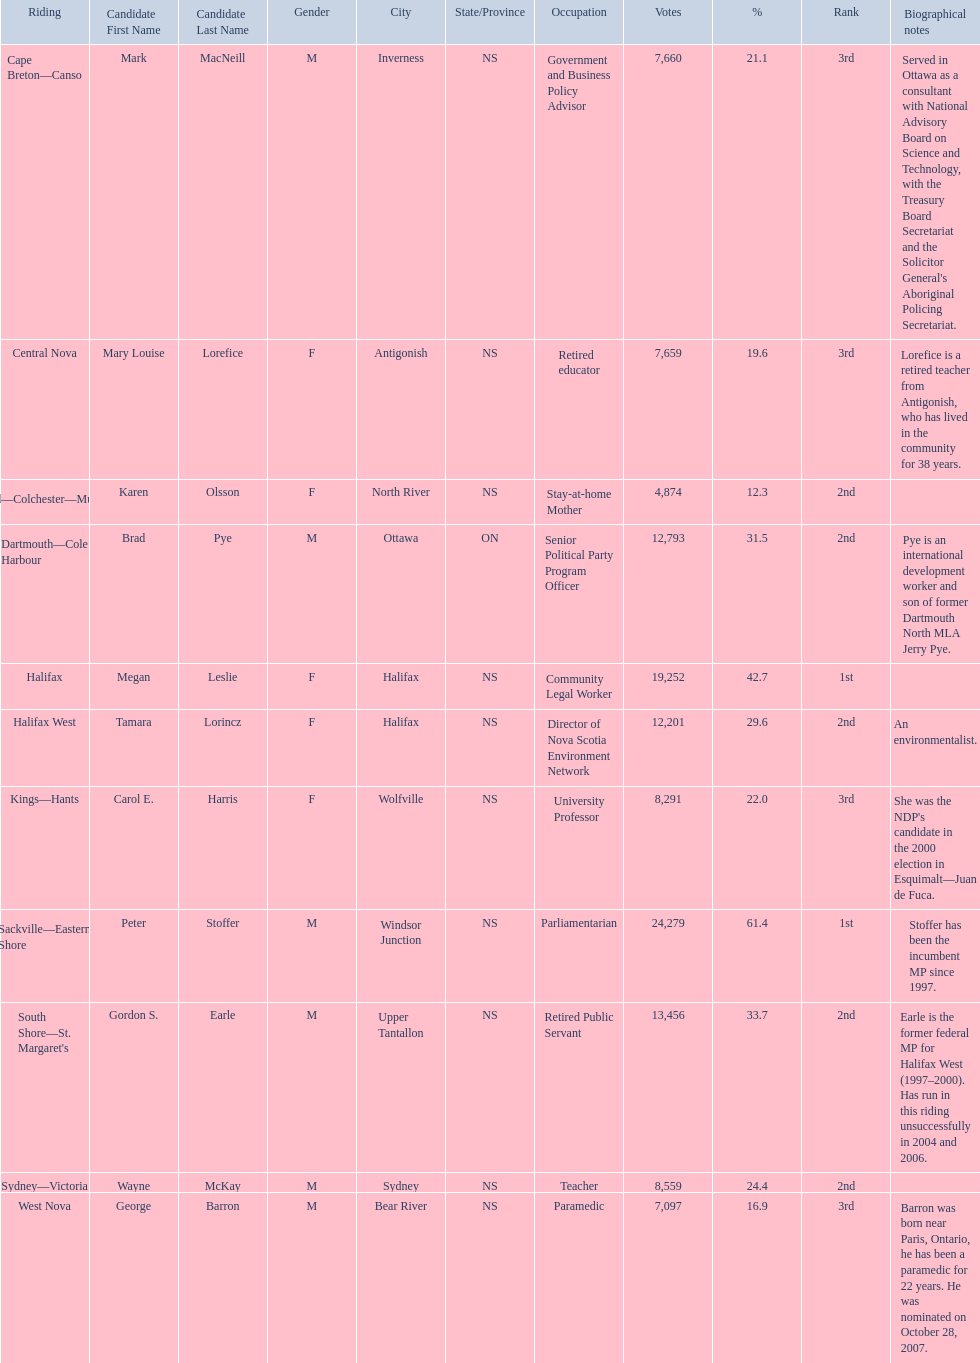How many votes did macneill receive? 7,660. How many votes did olsoon receive? 4,874. Between macneil and olsson, who received more votes? Mark MacNeill. 